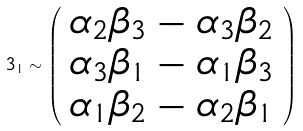<formula> <loc_0><loc_0><loc_500><loc_500>3 _ { 1 } \sim \left ( \begin{array} { c } \alpha _ { 2 } \beta _ { 3 } - \alpha _ { 3 } \beta _ { 2 } \\ \alpha _ { 3 } \beta _ { 1 } - \alpha _ { 1 } \beta _ { 3 } \\ \alpha _ { 1 } \beta _ { 2 } - \alpha _ { 2 } \beta _ { 1 } \end{array} \right )</formula> 